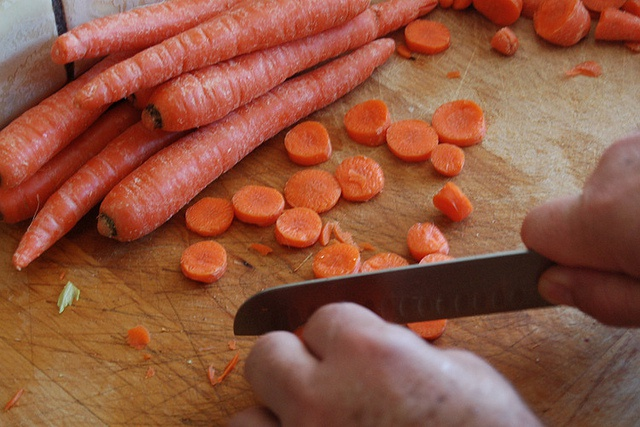Describe the objects in this image and their specific colors. I can see carrot in darkgray, brown, and salmon tones, people in darkgray, maroon, and brown tones, knife in darkgray, black, maroon, and gray tones, carrot in darkgray, brown, and maroon tones, and carrot in darkgray, red, salmon, and brown tones in this image. 